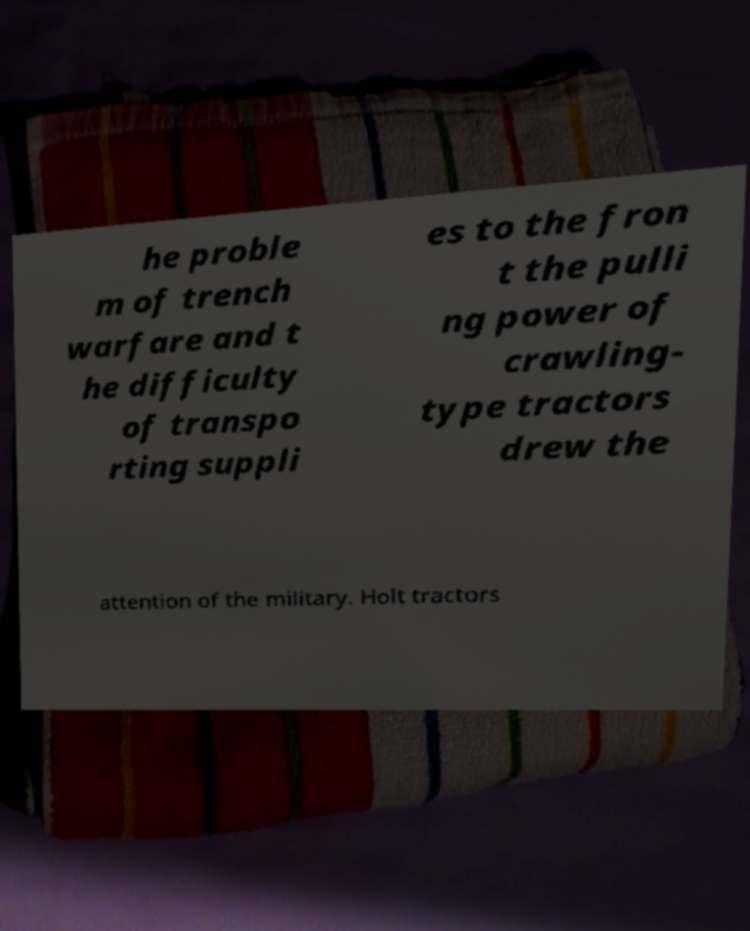Could you extract and type out the text from this image? he proble m of trench warfare and t he difficulty of transpo rting suppli es to the fron t the pulli ng power of crawling- type tractors drew the attention of the military. Holt tractors 